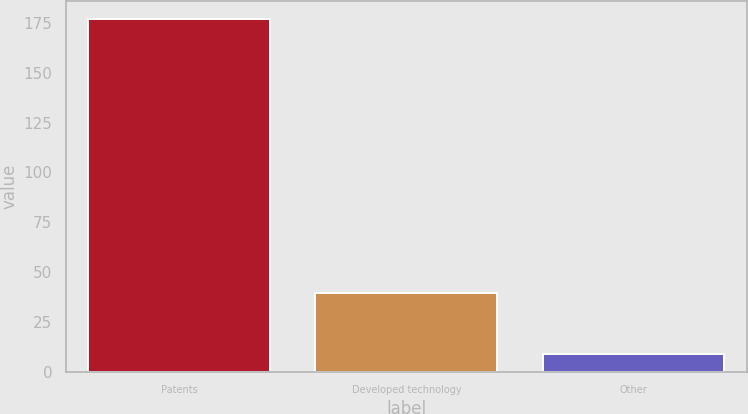Convert chart to OTSL. <chart><loc_0><loc_0><loc_500><loc_500><bar_chart><fcel>Patents<fcel>Developed technology<fcel>Other<nl><fcel>177<fcel>39.6<fcel>9<nl></chart> 